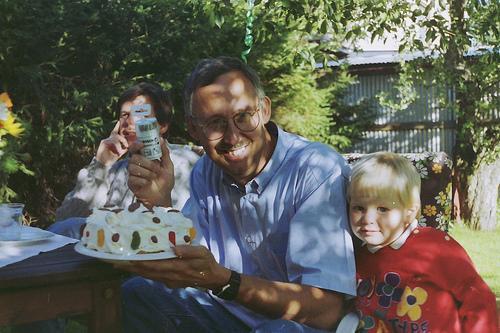How many people are wearing glasses?
Give a very brief answer. 1. 